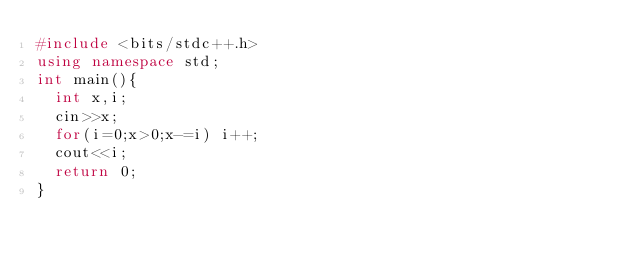Convert code to text. <code><loc_0><loc_0><loc_500><loc_500><_C++_>#include <bits/stdc++.h>
using namespace std;
int main(){
	int x,i;
	cin>>x;
	for(i=0;x>0;x-=i) i++;
	cout<<i;
	return 0;
}
</code> 